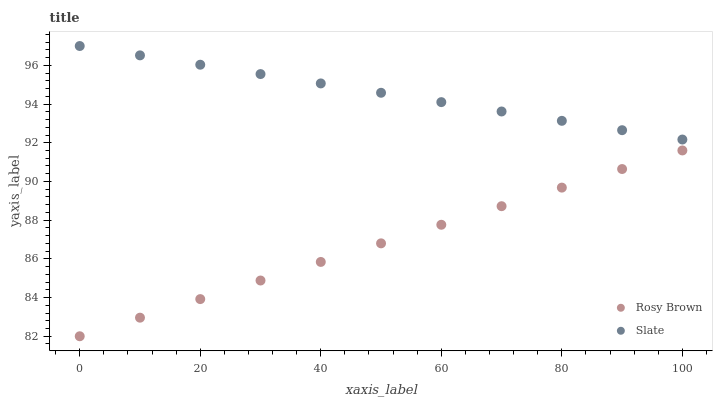Does Rosy Brown have the minimum area under the curve?
Answer yes or no. Yes. Does Slate have the maximum area under the curve?
Answer yes or no. Yes. Does Rosy Brown have the maximum area under the curve?
Answer yes or no. No. Is Rosy Brown the smoothest?
Answer yes or no. Yes. Is Slate the roughest?
Answer yes or no. Yes. Is Rosy Brown the roughest?
Answer yes or no. No. Does Rosy Brown have the lowest value?
Answer yes or no. Yes. Does Slate have the highest value?
Answer yes or no. Yes. Does Rosy Brown have the highest value?
Answer yes or no. No. Is Rosy Brown less than Slate?
Answer yes or no. Yes. Is Slate greater than Rosy Brown?
Answer yes or no. Yes. Does Rosy Brown intersect Slate?
Answer yes or no. No. 